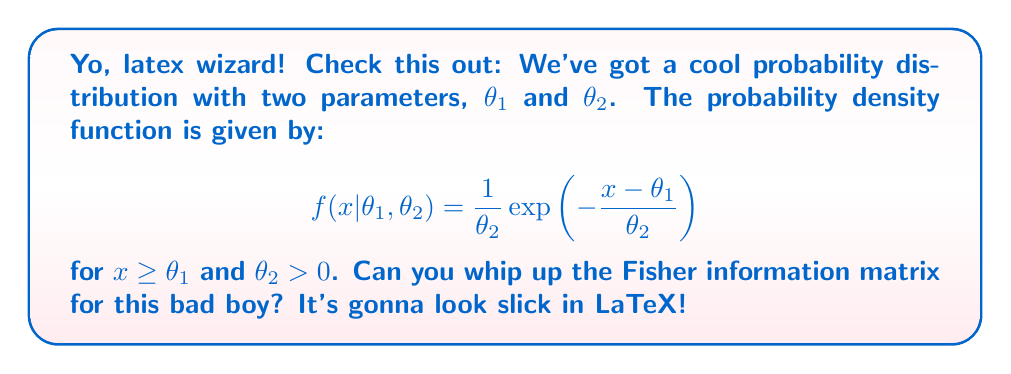Solve this math problem. Alright, let's break this down step by step:

1) The Fisher information matrix $I(\theta)$ is defined as:

   $$I(\theta) = E\left[\left(\frac{\partial}{\partial \theta} \log f(X|\theta)\right) \left(\frac{\partial}{\partial \theta} \log f(X|\theta)\right)^T\right]$$

2) First, we need to find $\log f(x|\theta_1,\theta_2)$:

   $$\log f(x|\theta_1,\theta_2) = -\log \theta_2 - \frac{x-\theta_1}{\theta_2}$$

3) Now, let's calculate the partial derivatives:

   $$\frac{\partial}{\partial \theta_1} \log f(x|\theta_1,\theta_2) = \frac{1}{\theta_2}$$

   $$\frac{\partial}{\partial \theta_2} \log f(x|\theta_1,\theta_2) = -\frac{1}{\theta_2} + \frac{x-\theta_1}{\theta_2^2}$$

4) The Fisher information matrix will be a 2x2 matrix:

   $$I(\theta) = \begin{bmatrix}
   E\left[\left(\frac{\partial}{\partial \theta_1} \log f\right)^2\right] & E\left[\frac{\partial}{\partial \theta_1} \log f \cdot \frac{\partial}{\partial \theta_2} \log f\right] \\
   E\left[\frac{\partial}{\partial \theta_1} \log f \cdot \frac{\partial}{\partial \theta_2} \log f\right] & E\left[\left(\frac{\partial}{\partial \theta_2} \log f\right)^2\right]
   \end{bmatrix}$$

5) Let's calculate each element:

   $I_{11} = E\left[\left(\frac{1}{\theta_2}\right)^2\right] = \frac{1}{\theta_2^2}$

   $I_{12} = I_{21} = E\left[\frac{1}{\theta_2} \cdot \left(-\frac{1}{\theta_2} + \frac{x-\theta_1}{\theta_2^2}\right)\right] = -\frac{1}{\theta_2^2} + \frac{1}{\theta_2^3}E[x-\theta_1] = 0$

   $I_{22} = E\left[\left(-\frac{1}{\theta_2} + \frac{x-\theta_1}{\theta_2^2}\right)^2\right] = \frac{1}{\theta_2^2} + \frac{2}{\theta_2^3}E[x-\theta_1] + \frac{1}{\theta_2^4}E[(x-\theta_1)^2] = \frac{2}{\theta_2^2}$

6) Therefore, the Fisher information matrix is:

   $$I(\theta) = \begin{bmatrix}
   \frac{1}{\theta_2^2} & 0 \\
   0 & \frac{2}{\theta_2^2}
   \end{bmatrix}$$
Answer: $$I(\theta) = \begin{bmatrix}
\frac{1}{\theta_2^2} & 0 \\
0 & \frac{2}{\theta_2^2}
\end{bmatrix}$$ 